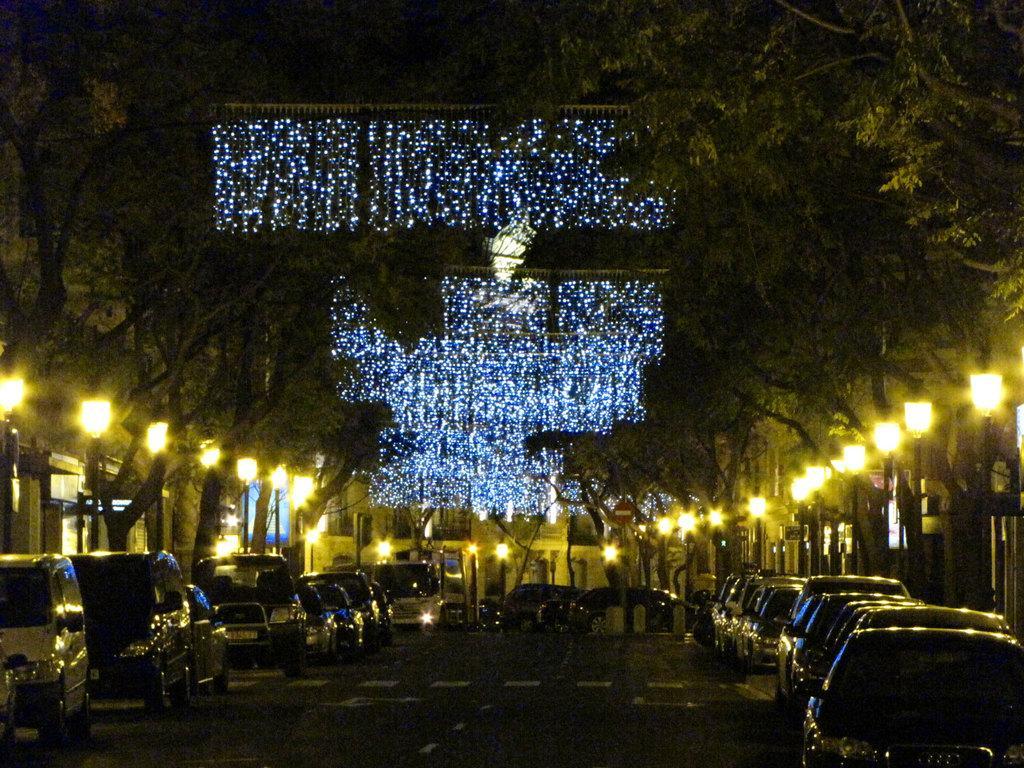Could you give a brief overview of what you see in this image? In this image we can see road, vehicles, lights, trees, and buildings. 